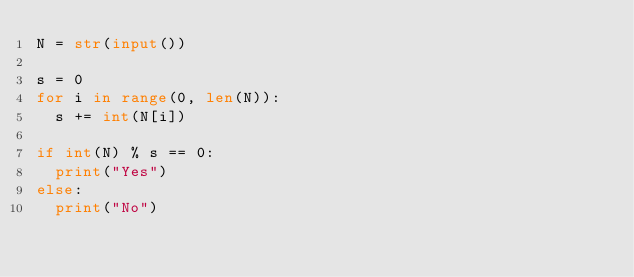<code> <loc_0><loc_0><loc_500><loc_500><_Python_>N = str(input())

s = 0
for i in range(0, len(N)):
  s += int(N[i])

if int(N) % s == 0:
  print("Yes")
else:
  print("No")</code> 